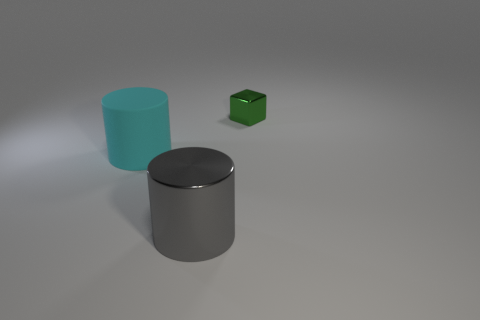Add 1 big metallic objects. How many objects exist? 4 Subtract all cyan cylinders. How many cylinders are left? 1 Subtract 1 cubes. How many cubes are left? 0 Subtract all brown cubes. Subtract all gray balls. How many cubes are left? 1 Subtract all gray balls. How many cyan cylinders are left? 1 Subtract all big cyan rubber cylinders. Subtract all tiny gray rubber cylinders. How many objects are left? 2 Add 2 gray shiny objects. How many gray shiny objects are left? 3 Add 1 large gray metallic objects. How many large gray metallic objects exist? 2 Subtract 0 red balls. How many objects are left? 3 Subtract all cubes. How many objects are left? 2 